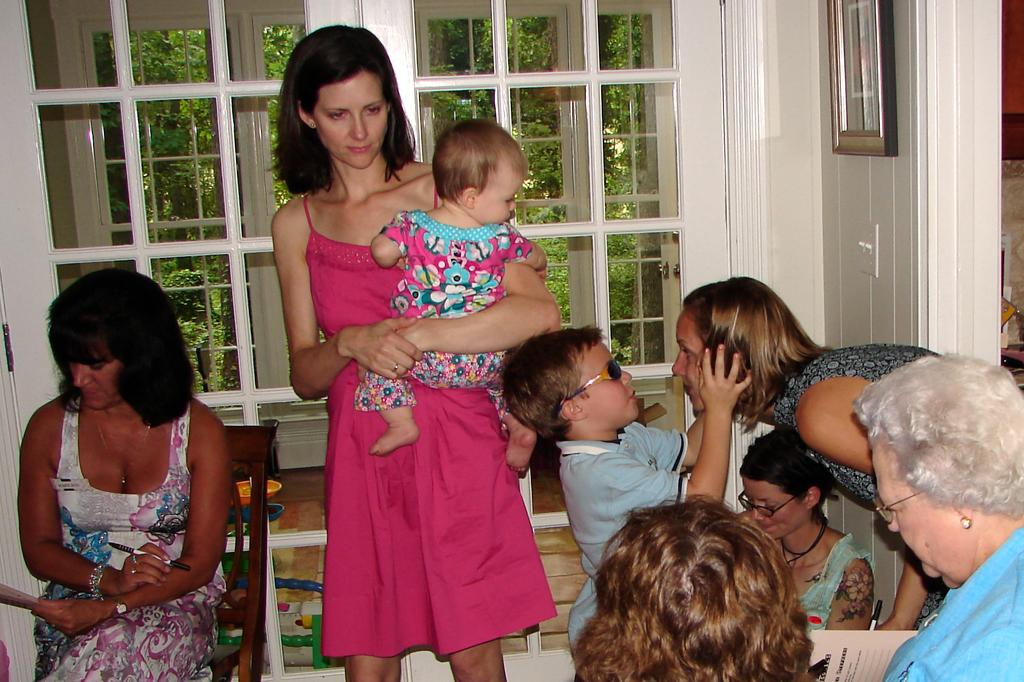What is the woman doing in the image? The woman is carrying a baby in the image. Can you describe the setting of the image? There are people in the image, and trees are visible through the glass windows. What is on the wall in the image? The image has a picture on the wall. What is the woman's position in the image? The woman is sitting on a chair. What object is the woman holding in the image? The woman is holding a pen. What is the condition of the baby's dad in the image? There is no information about the baby's dad in the image, so we cannot determine their condition. 